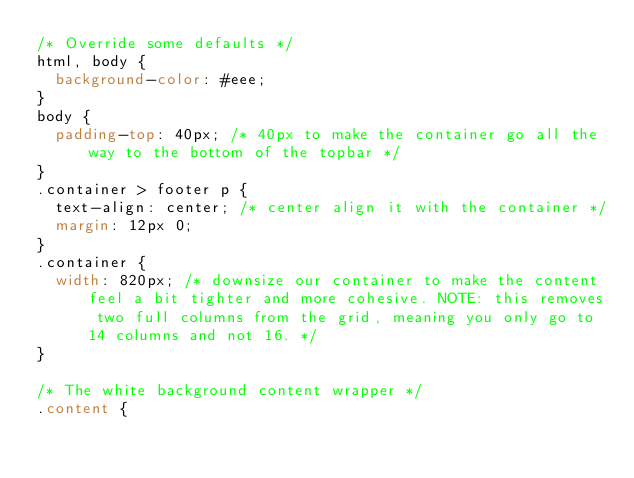<code> <loc_0><loc_0><loc_500><loc_500><_CSS_>/* Override some defaults */
html, body {
  background-color: #eee;
}
body {
  padding-top: 40px; /* 40px to make the container go all the way to the bottom of the topbar */
}
.container > footer p {
  text-align: center; /* center align it with the container */
  margin: 12px 0;
}
.container {
  width: 820px; /* downsize our container to make the content feel a bit tighter and more cohesive. NOTE: this removes two full columns from the grid, meaning you only go to 14 columns and not 16. */
}

/* The white background content wrapper */
.content {</code> 